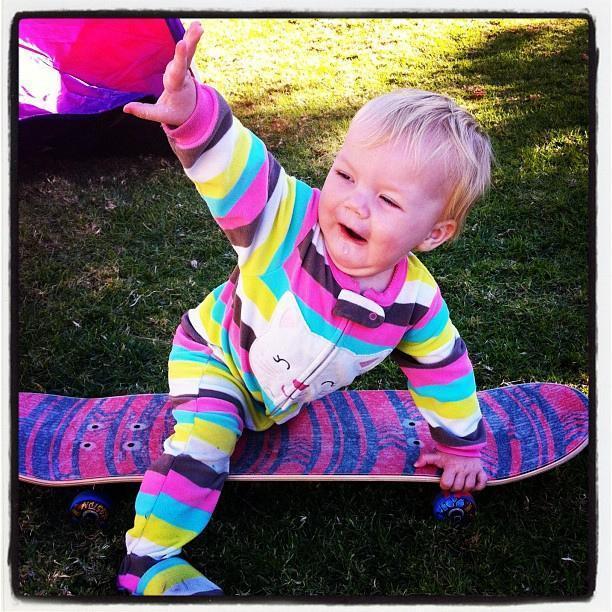How many mice do you see?
Give a very brief answer. 0. 